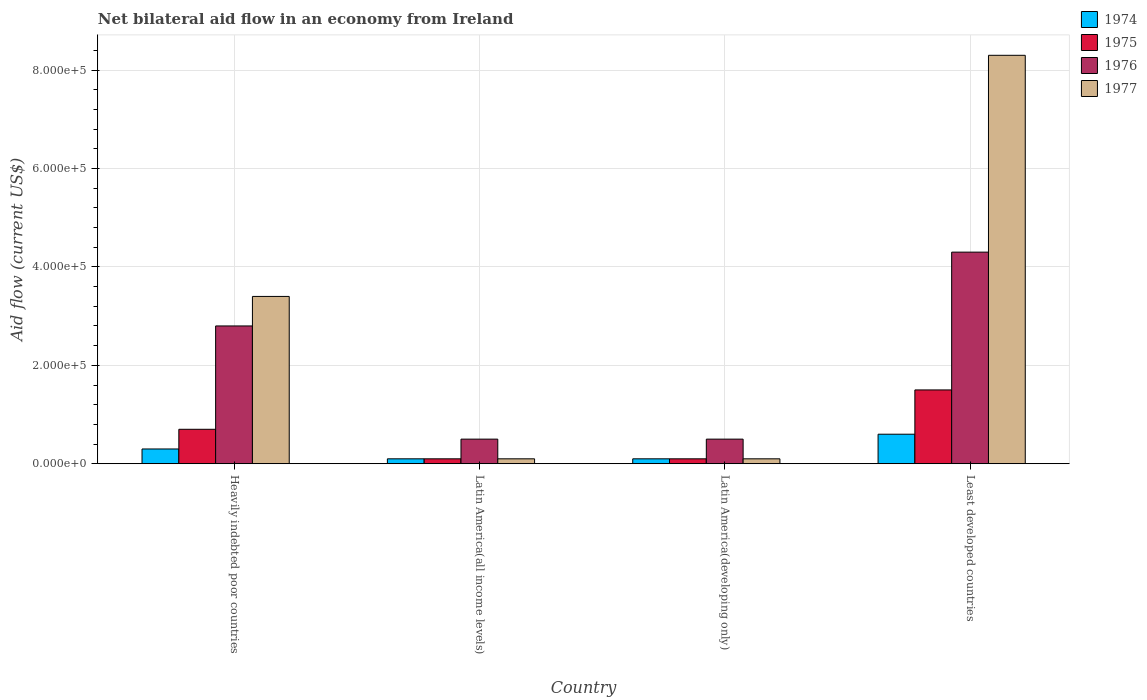How many different coloured bars are there?
Provide a succinct answer. 4. How many groups of bars are there?
Ensure brevity in your answer.  4. Are the number of bars per tick equal to the number of legend labels?
Offer a very short reply. Yes. Are the number of bars on each tick of the X-axis equal?
Your answer should be very brief. Yes. How many bars are there on the 1st tick from the right?
Keep it short and to the point. 4. What is the label of the 3rd group of bars from the left?
Give a very brief answer. Latin America(developing only). In which country was the net bilateral aid flow in 1974 maximum?
Offer a very short reply. Least developed countries. In which country was the net bilateral aid flow in 1976 minimum?
Offer a very short reply. Latin America(all income levels). What is the total net bilateral aid flow in 1976 in the graph?
Your answer should be very brief. 8.10e+05. What is the difference between the net bilateral aid flow in 1975 in Heavily indebted poor countries and the net bilateral aid flow in 1977 in Least developed countries?
Ensure brevity in your answer.  -7.60e+05. What is the average net bilateral aid flow in 1977 per country?
Offer a very short reply. 2.98e+05. In how many countries, is the net bilateral aid flow in 1977 greater than 40000 US$?
Make the answer very short. 2. What is the ratio of the net bilateral aid flow in 1976 in Latin America(all income levels) to that in Least developed countries?
Offer a terse response. 0.12. What is the difference between the highest and the second highest net bilateral aid flow in 1977?
Offer a terse response. 8.20e+05. What is the difference between the highest and the lowest net bilateral aid flow in 1977?
Offer a terse response. 8.20e+05. Is the sum of the net bilateral aid flow in 1976 in Heavily indebted poor countries and Latin America(all income levels) greater than the maximum net bilateral aid flow in 1977 across all countries?
Offer a very short reply. No. Is it the case that in every country, the sum of the net bilateral aid flow in 1976 and net bilateral aid flow in 1975 is greater than the sum of net bilateral aid flow in 1974 and net bilateral aid flow in 1977?
Your answer should be compact. No. What does the 3rd bar from the left in Latin America(all income levels) represents?
Your answer should be compact. 1976. What does the 2nd bar from the right in Latin America(developing only) represents?
Provide a short and direct response. 1976. Is it the case that in every country, the sum of the net bilateral aid flow in 1976 and net bilateral aid flow in 1977 is greater than the net bilateral aid flow in 1975?
Make the answer very short. Yes. Are all the bars in the graph horizontal?
Offer a terse response. No. What is the difference between two consecutive major ticks on the Y-axis?
Your answer should be very brief. 2.00e+05. Does the graph contain any zero values?
Offer a very short reply. No. Where does the legend appear in the graph?
Your answer should be compact. Top right. How are the legend labels stacked?
Your answer should be compact. Vertical. What is the title of the graph?
Offer a terse response. Net bilateral aid flow in an economy from Ireland. What is the label or title of the Y-axis?
Offer a terse response. Aid flow (current US$). What is the Aid flow (current US$) of 1974 in Heavily indebted poor countries?
Keep it short and to the point. 3.00e+04. What is the Aid flow (current US$) in 1976 in Heavily indebted poor countries?
Your answer should be compact. 2.80e+05. What is the Aid flow (current US$) of 1974 in Latin America(all income levels)?
Keep it short and to the point. 10000. What is the Aid flow (current US$) of 1974 in Latin America(developing only)?
Your response must be concise. 10000. What is the Aid flow (current US$) of 1975 in Latin America(developing only)?
Give a very brief answer. 10000. What is the Aid flow (current US$) in 1976 in Latin America(developing only)?
Keep it short and to the point. 5.00e+04. What is the Aid flow (current US$) of 1977 in Latin America(developing only)?
Offer a very short reply. 10000. What is the Aid flow (current US$) of 1974 in Least developed countries?
Keep it short and to the point. 6.00e+04. What is the Aid flow (current US$) in 1975 in Least developed countries?
Your answer should be very brief. 1.50e+05. What is the Aid flow (current US$) of 1977 in Least developed countries?
Your answer should be compact. 8.30e+05. Across all countries, what is the maximum Aid flow (current US$) in 1976?
Provide a succinct answer. 4.30e+05. Across all countries, what is the maximum Aid flow (current US$) of 1977?
Provide a succinct answer. 8.30e+05. Across all countries, what is the minimum Aid flow (current US$) of 1974?
Provide a succinct answer. 10000. Across all countries, what is the minimum Aid flow (current US$) in 1975?
Offer a terse response. 10000. Across all countries, what is the minimum Aid flow (current US$) of 1976?
Your answer should be compact. 5.00e+04. Across all countries, what is the minimum Aid flow (current US$) of 1977?
Your answer should be very brief. 10000. What is the total Aid flow (current US$) in 1976 in the graph?
Ensure brevity in your answer.  8.10e+05. What is the total Aid flow (current US$) in 1977 in the graph?
Your answer should be compact. 1.19e+06. What is the difference between the Aid flow (current US$) in 1976 in Heavily indebted poor countries and that in Latin America(all income levels)?
Keep it short and to the point. 2.30e+05. What is the difference between the Aid flow (current US$) in 1977 in Heavily indebted poor countries and that in Latin America(all income levels)?
Your answer should be very brief. 3.30e+05. What is the difference between the Aid flow (current US$) in 1975 in Heavily indebted poor countries and that in Latin America(developing only)?
Provide a short and direct response. 6.00e+04. What is the difference between the Aid flow (current US$) of 1977 in Heavily indebted poor countries and that in Latin America(developing only)?
Give a very brief answer. 3.30e+05. What is the difference between the Aid flow (current US$) in 1974 in Heavily indebted poor countries and that in Least developed countries?
Provide a succinct answer. -3.00e+04. What is the difference between the Aid flow (current US$) of 1975 in Heavily indebted poor countries and that in Least developed countries?
Your response must be concise. -8.00e+04. What is the difference between the Aid flow (current US$) in 1977 in Heavily indebted poor countries and that in Least developed countries?
Make the answer very short. -4.90e+05. What is the difference between the Aid flow (current US$) of 1974 in Latin America(all income levels) and that in Latin America(developing only)?
Make the answer very short. 0. What is the difference between the Aid flow (current US$) of 1975 in Latin America(all income levels) and that in Latin America(developing only)?
Offer a very short reply. 0. What is the difference between the Aid flow (current US$) of 1975 in Latin America(all income levels) and that in Least developed countries?
Offer a very short reply. -1.40e+05. What is the difference between the Aid flow (current US$) in 1976 in Latin America(all income levels) and that in Least developed countries?
Ensure brevity in your answer.  -3.80e+05. What is the difference between the Aid flow (current US$) of 1977 in Latin America(all income levels) and that in Least developed countries?
Provide a short and direct response. -8.20e+05. What is the difference between the Aid flow (current US$) of 1974 in Latin America(developing only) and that in Least developed countries?
Keep it short and to the point. -5.00e+04. What is the difference between the Aid flow (current US$) of 1976 in Latin America(developing only) and that in Least developed countries?
Provide a short and direct response. -3.80e+05. What is the difference between the Aid flow (current US$) of 1977 in Latin America(developing only) and that in Least developed countries?
Your answer should be compact. -8.20e+05. What is the difference between the Aid flow (current US$) of 1974 in Heavily indebted poor countries and the Aid flow (current US$) of 1977 in Latin America(all income levels)?
Your response must be concise. 2.00e+04. What is the difference between the Aid flow (current US$) of 1975 in Heavily indebted poor countries and the Aid flow (current US$) of 1976 in Latin America(all income levels)?
Your response must be concise. 2.00e+04. What is the difference between the Aid flow (current US$) in 1974 in Heavily indebted poor countries and the Aid flow (current US$) in 1977 in Latin America(developing only)?
Offer a terse response. 2.00e+04. What is the difference between the Aid flow (current US$) in 1975 in Heavily indebted poor countries and the Aid flow (current US$) in 1977 in Latin America(developing only)?
Keep it short and to the point. 6.00e+04. What is the difference between the Aid flow (current US$) in 1974 in Heavily indebted poor countries and the Aid flow (current US$) in 1976 in Least developed countries?
Your answer should be very brief. -4.00e+05. What is the difference between the Aid flow (current US$) of 1974 in Heavily indebted poor countries and the Aid flow (current US$) of 1977 in Least developed countries?
Offer a terse response. -8.00e+05. What is the difference between the Aid flow (current US$) in 1975 in Heavily indebted poor countries and the Aid flow (current US$) in 1976 in Least developed countries?
Give a very brief answer. -3.60e+05. What is the difference between the Aid flow (current US$) in 1975 in Heavily indebted poor countries and the Aid flow (current US$) in 1977 in Least developed countries?
Your answer should be compact. -7.60e+05. What is the difference between the Aid flow (current US$) in 1976 in Heavily indebted poor countries and the Aid flow (current US$) in 1977 in Least developed countries?
Your answer should be very brief. -5.50e+05. What is the difference between the Aid flow (current US$) in 1974 in Latin America(all income levels) and the Aid flow (current US$) in 1975 in Latin America(developing only)?
Make the answer very short. 0. What is the difference between the Aid flow (current US$) of 1975 in Latin America(all income levels) and the Aid flow (current US$) of 1977 in Latin America(developing only)?
Your response must be concise. 0. What is the difference between the Aid flow (current US$) in 1976 in Latin America(all income levels) and the Aid flow (current US$) in 1977 in Latin America(developing only)?
Give a very brief answer. 4.00e+04. What is the difference between the Aid flow (current US$) of 1974 in Latin America(all income levels) and the Aid flow (current US$) of 1976 in Least developed countries?
Offer a terse response. -4.20e+05. What is the difference between the Aid flow (current US$) of 1974 in Latin America(all income levels) and the Aid flow (current US$) of 1977 in Least developed countries?
Provide a short and direct response. -8.20e+05. What is the difference between the Aid flow (current US$) in 1975 in Latin America(all income levels) and the Aid flow (current US$) in 1976 in Least developed countries?
Keep it short and to the point. -4.20e+05. What is the difference between the Aid flow (current US$) in 1975 in Latin America(all income levels) and the Aid flow (current US$) in 1977 in Least developed countries?
Keep it short and to the point. -8.20e+05. What is the difference between the Aid flow (current US$) of 1976 in Latin America(all income levels) and the Aid flow (current US$) of 1977 in Least developed countries?
Give a very brief answer. -7.80e+05. What is the difference between the Aid flow (current US$) in 1974 in Latin America(developing only) and the Aid flow (current US$) in 1975 in Least developed countries?
Ensure brevity in your answer.  -1.40e+05. What is the difference between the Aid flow (current US$) of 1974 in Latin America(developing only) and the Aid flow (current US$) of 1976 in Least developed countries?
Your answer should be compact. -4.20e+05. What is the difference between the Aid flow (current US$) in 1974 in Latin America(developing only) and the Aid flow (current US$) in 1977 in Least developed countries?
Your response must be concise. -8.20e+05. What is the difference between the Aid flow (current US$) in 1975 in Latin America(developing only) and the Aid flow (current US$) in 1976 in Least developed countries?
Provide a short and direct response. -4.20e+05. What is the difference between the Aid flow (current US$) of 1975 in Latin America(developing only) and the Aid flow (current US$) of 1977 in Least developed countries?
Offer a terse response. -8.20e+05. What is the difference between the Aid flow (current US$) in 1976 in Latin America(developing only) and the Aid flow (current US$) in 1977 in Least developed countries?
Your answer should be very brief. -7.80e+05. What is the average Aid flow (current US$) of 1974 per country?
Keep it short and to the point. 2.75e+04. What is the average Aid flow (current US$) in 1976 per country?
Your answer should be very brief. 2.02e+05. What is the average Aid flow (current US$) in 1977 per country?
Make the answer very short. 2.98e+05. What is the difference between the Aid flow (current US$) in 1974 and Aid flow (current US$) in 1976 in Heavily indebted poor countries?
Provide a succinct answer. -2.50e+05. What is the difference between the Aid flow (current US$) in 1974 and Aid flow (current US$) in 1977 in Heavily indebted poor countries?
Ensure brevity in your answer.  -3.10e+05. What is the difference between the Aid flow (current US$) in 1975 and Aid flow (current US$) in 1977 in Heavily indebted poor countries?
Make the answer very short. -2.70e+05. What is the difference between the Aid flow (current US$) in 1974 and Aid flow (current US$) in 1975 in Latin America(all income levels)?
Give a very brief answer. 0. What is the difference between the Aid flow (current US$) in 1974 and Aid flow (current US$) in 1976 in Latin America(all income levels)?
Ensure brevity in your answer.  -4.00e+04. What is the difference between the Aid flow (current US$) of 1974 and Aid flow (current US$) of 1977 in Latin America(all income levels)?
Make the answer very short. 0. What is the difference between the Aid flow (current US$) of 1976 and Aid flow (current US$) of 1977 in Latin America(all income levels)?
Give a very brief answer. 4.00e+04. What is the difference between the Aid flow (current US$) of 1974 and Aid flow (current US$) of 1977 in Latin America(developing only)?
Make the answer very short. 0. What is the difference between the Aid flow (current US$) in 1975 and Aid flow (current US$) in 1976 in Latin America(developing only)?
Offer a very short reply. -4.00e+04. What is the difference between the Aid flow (current US$) of 1975 and Aid flow (current US$) of 1977 in Latin America(developing only)?
Make the answer very short. 0. What is the difference between the Aid flow (current US$) of 1974 and Aid flow (current US$) of 1975 in Least developed countries?
Make the answer very short. -9.00e+04. What is the difference between the Aid flow (current US$) in 1974 and Aid flow (current US$) in 1976 in Least developed countries?
Give a very brief answer. -3.70e+05. What is the difference between the Aid flow (current US$) in 1974 and Aid flow (current US$) in 1977 in Least developed countries?
Make the answer very short. -7.70e+05. What is the difference between the Aid flow (current US$) in 1975 and Aid flow (current US$) in 1976 in Least developed countries?
Give a very brief answer. -2.80e+05. What is the difference between the Aid flow (current US$) of 1975 and Aid flow (current US$) of 1977 in Least developed countries?
Your answer should be compact. -6.80e+05. What is the difference between the Aid flow (current US$) in 1976 and Aid flow (current US$) in 1977 in Least developed countries?
Provide a succinct answer. -4.00e+05. What is the ratio of the Aid flow (current US$) of 1977 in Heavily indebted poor countries to that in Latin America(all income levels)?
Offer a very short reply. 34. What is the ratio of the Aid flow (current US$) of 1974 in Heavily indebted poor countries to that in Latin America(developing only)?
Offer a terse response. 3. What is the ratio of the Aid flow (current US$) in 1977 in Heavily indebted poor countries to that in Latin America(developing only)?
Your answer should be very brief. 34. What is the ratio of the Aid flow (current US$) in 1975 in Heavily indebted poor countries to that in Least developed countries?
Your response must be concise. 0.47. What is the ratio of the Aid flow (current US$) of 1976 in Heavily indebted poor countries to that in Least developed countries?
Offer a terse response. 0.65. What is the ratio of the Aid flow (current US$) of 1977 in Heavily indebted poor countries to that in Least developed countries?
Offer a very short reply. 0.41. What is the ratio of the Aid flow (current US$) of 1975 in Latin America(all income levels) to that in Latin America(developing only)?
Your answer should be very brief. 1. What is the ratio of the Aid flow (current US$) in 1976 in Latin America(all income levels) to that in Latin America(developing only)?
Make the answer very short. 1. What is the ratio of the Aid flow (current US$) of 1977 in Latin America(all income levels) to that in Latin America(developing only)?
Provide a short and direct response. 1. What is the ratio of the Aid flow (current US$) of 1974 in Latin America(all income levels) to that in Least developed countries?
Offer a terse response. 0.17. What is the ratio of the Aid flow (current US$) of 1975 in Latin America(all income levels) to that in Least developed countries?
Your answer should be compact. 0.07. What is the ratio of the Aid flow (current US$) of 1976 in Latin America(all income levels) to that in Least developed countries?
Give a very brief answer. 0.12. What is the ratio of the Aid flow (current US$) in 1977 in Latin America(all income levels) to that in Least developed countries?
Your answer should be compact. 0.01. What is the ratio of the Aid flow (current US$) in 1974 in Latin America(developing only) to that in Least developed countries?
Ensure brevity in your answer.  0.17. What is the ratio of the Aid flow (current US$) in 1975 in Latin America(developing only) to that in Least developed countries?
Offer a terse response. 0.07. What is the ratio of the Aid flow (current US$) of 1976 in Latin America(developing only) to that in Least developed countries?
Offer a terse response. 0.12. What is the ratio of the Aid flow (current US$) in 1977 in Latin America(developing only) to that in Least developed countries?
Provide a short and direct response. 0.01. What is the difference between the highest and the second highest Aid flow (current US$) in 1975?
Ensure brevity in your answer.  8.00e+04. What is the difference between the highest and the lowest Aid flow (current US$) in 1974?
Give a very brief answer. 5.00e+04. What is the difference between the highest and the lowest Aid flow (current US$) in 1975?
Your response must be concise. 1.40e+05. What is the difference between the highest and the lowest Aid flow (current US$) in 1976?
Give a very brief answer. 3.80e+05. What is the difference between the highest and the lowest Aid flow (current US$) in 1977?
Ensure brevity in your answer.  8.20e+05. 